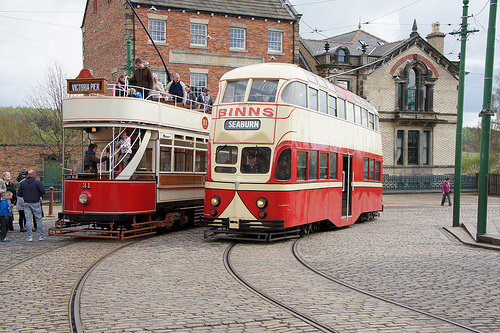<image>
Is there a bus to the left of the human? No. The bus is not to the left of the human. From this viewpoint, they have a different horizontal relationship. Is the chimney behind the cobblestone? Yes. From this viewpoint, the chimney is positioned behind the cobblestone, with the cobblestone partially or fully occluding the chimney. 